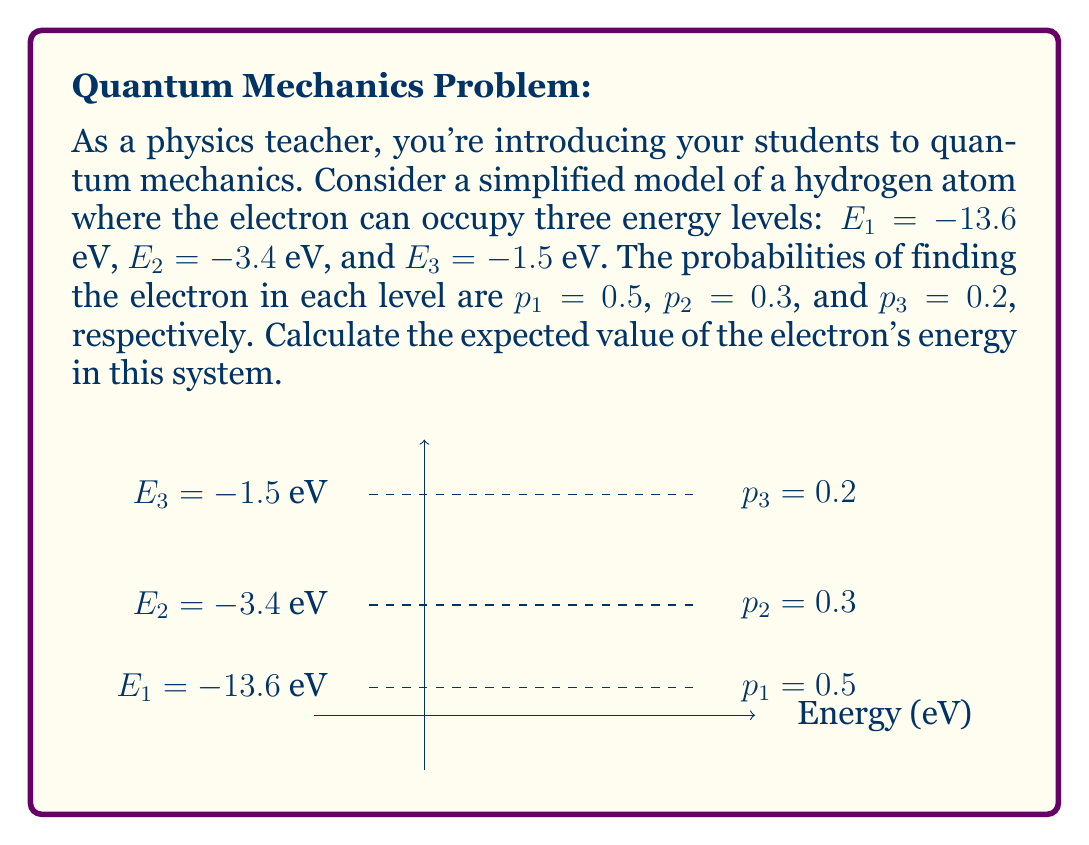Give your solution to this math problem. To calculate the expected value of the electron's energy, we need to use the formula for expected value:

$$E(X) = \sum_{i=1}^{n} x_i \cdot p_i$$

Where $x_i$ represents each possible value of the random variable X, and $p_i$ is the probability of that value occurring.

Let's follow these steps:

1) Identify the values and their probabilities:
   $E_1 = -13.6$ eV, $p_1 = 0.5$
   $E_2 = -3.4$ eV, $p_2 = 0.3$
   $E_3 = -1.5$ eV, $p_3 = 0.2$

2) Apply the expected value formula:
   $$E(X) = E_1 \cdot p_1 + E_2 \cdot p_2 + E_3 \cdot p_3$$

3) Substitute the values:
   $$E(X) = (-13.6 \cdot 0.5) + (-3.4 \cdot 0.3) + (-1.5 \cdot 0.2)$$

4) Calculate each term:
   $$E(X) = -6.8 + (-1.02) + (-0.3)$$

5) Sum up the terms:
   $$E(X) = -8.12 \text{ eV}$$

Therefore, the expected value of the electron's energy in this simplified hydrogen atom model is -8.12 eV.
Answer: $-8.12 \text{ eV}$ 